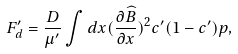Convert formula to latex. <formula><loc_0><loc_0><loc_500><loc_500>F ^ { \prime } _ { d } = \frac { D } { \mu ^ { \prime } } \int d x ( \frac { \partial { \widehat { B } } } { \partial { x } } ) ^ { 2 } c ^ { \prime } ( 1 - c ^ { \prime } ) p ,</formula> 